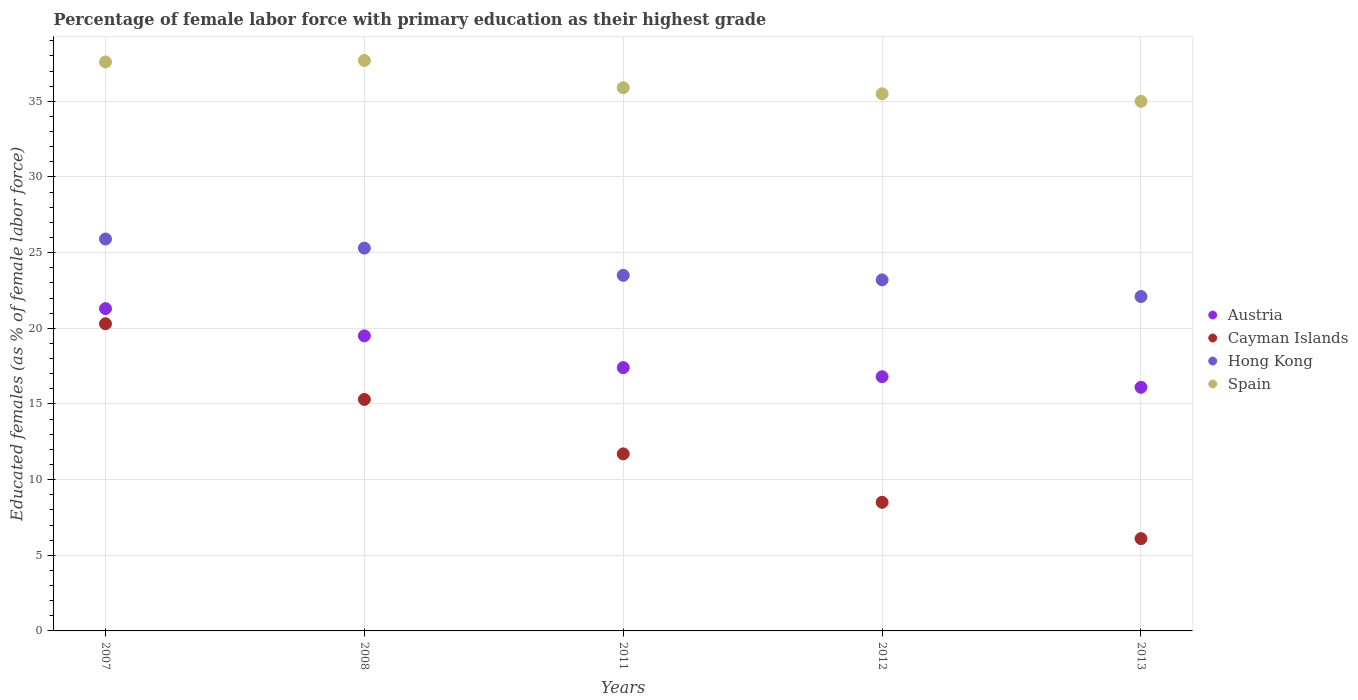Is the number of dotlines equal to the number of legend labels?
Your answer should be very brief. Yes. What is the percentage of female labor force with primary education in Hong Kong in 2012?
Give a very brief answer. 23.2. Across all years, what is the maximum percentage of female labor force with primary education in Cayman Islands?
Offer a very short reply. 20.3. Across all years, what is the minimum percentage of female labor force with primary education in Cayman Islands?
Give a very brief answer. 6.1. In which year was the percentage of female labor force with primary education in Cayman Islands maximum?
Ensure brevity in your answer.  2007. In which year was the percentage of female labor force with primary education in Hong Kong minimum?
Keep it short and to the point. 2013. What is the total percentage of female labor force with primary education in Cayman Islands in the graph?
Give a very brief answer. 61.9. What is the difference between the percentage of female labor force with primary education in Hong Kong in 2012 and that in 2013?
Your response must be concise. 1.1. What is the difference between the percentage of female labor force with primary education in Spain in 2011 and the percentage of female labor force with primary education in Hong Kong in 2007?
Keep it short and to the point. 10. What is the average percentage of female labor force with primary education in Hong Kong per year?
Provide a short and direct response. 24. What is the ratio of the percentage of female labor force with primary education in Cayman Islands in 2011 to that in 2012?
Make the answer very short. 1.38. What is the difference between the highest and the second highest percentage of female labor force with primary education in Hong Kong?
Ensure brevity in your answer.  0.6. What is the difference between the highest and the lowest percentage of female labor force with primary education in Hong Kong?
Offer a very short reply. 3.8. In how many years, is the percentage of female labor force with primary education in Hong Kong greater than the average percentage of female labor force with primary education in Hong Kong taken over all years?
Make the answer very short. 2. Is the sum of the percentage of female labor force with primary education in Hong Kong in 2007 and 2012 greater than the maximum percentage of female labor force with primary education in Cayman Islands across all years?
Ensure brevity in your answer.  Yes. Is it the case that in every year, the sum of the percentage of female labor force with primary education in Spain and percentage of female labor force with primary education in Austria  is greater than the sum of percentage of female labor force with primary education in Hong Kong and percentage of female labor force with primary education in Cayman Islands?
Give a very brief answer. No. Does the percentage of female labor force with primary education in Austria monotonically increase over the years?
Ensure brevity in your answer.  No. What is the difference between two consecutive major ticks on the Y-axis?
Ensure brevity in your answer.  5. Are the values on the major ticks of Y-axis written in scientific E-notation?
Your answer should be very brief. No. Where does the legend appear in the graph?
Provide a succinct answer. Center right. How many legend labels are there?
Ensure brevity in your answer.  4. How are the legend labels stacked?
Your response must be concise. Vertical. What is the title of the graph?
Your answer should be compact. Percentage of female labor force with primary education as their highest grade. What is the label or title of the Y-axis?
Offer a terse response. Educated females (as % of female labor force). What is the Educated females (as % of female labor force) of Austria in 2007?
Offer a very short reply. 21.3. What is the Educated females (as % of female labor force) of Cayman Islands in 2007?
Your response must be concise. 20.3. What is the Educated females (as % of female labor force) in Hong Kong in 2007?
Your response must be concise. 25.9. What is the Educated females (as % of female labor force) of Spain in 2007?
Provide a short and direct response. 37.6. What is the Educated females (as % of female labor force) of Austria in 2008?
Offer a terse response. 19.5. What is the Educated females (as % of female labor force) in Cayman Islands in 2008?
Offer a very short reply. 15.3. What is the Educated females (as % of female labor force) of Hong Kong in 2008?
Make the answer very short. 25.3. What is the Educated females (as % of female labor force) of Spain in 2008?
Offer a very short reply. 37.7. What is the Educated females (as % of female labor force) of Austria in 2011?
Your answer should be very brief. 17.4. What is the Educated females (as % of female labor force) of Cayman Islands in 2011?
Your answer should be very brief. 11.7. What is the Educated females (as % of female labor force) of Spain in 2011?
Ensure brevity in your answer.  35.9. What is the Educated females (as % of female labor force) of Austria in 2012?
Your response must be concise. 16.8. What is the Educated females (as % of female labor force) in Hong Kong in 2012?
Your answer should be very brief. 23.2. What is the Educated females (as % of female labor force) of Spain in 2012?
Keep it short and to the point. 35.5. What is the Educated females (as % of female labor force) in Austria in 2013?
Give a very brief answer. 16.1. What is the Educated females (as % of female labor force) in Cayman Islands in 2013?
Your response must be concise. 6.1. What is the Educated females (as % of female labor force) in Hong Kong in 2013?
Offer a very short reply. 22.1. Across all years, what is the maximum Educated females (as % of female labor force) in Austria?
Your answer should be very brief. 21.3. Across all years, what is the maximum Educated females (as % of female labor force) of Cayman Islands?
Your response must be concise. 20.3. Across all years, what is the maximum Educated females (as % of female labor force) of Hong Kong?
Offer a very short reply. 25.9. Across all years, what is the maximum Educated females (as % of female labor force) in Spain?
Provide a short and direct response. 37.7. Across all years, what is the minimum Educated females (as % of female labor force) in Austria?
Offer a terse response. 16.1. Across all years, what is the minimum Educated females (as % of female labor force) in Cayman Islands?
Keep it short and to the point. 6.1. Across all years, what is the minimum Educated females (as % of female labor force) of Hong Kong?
Offer a terse response. 22.1. Across all years, what is the minimum Educated females (as % of female labor force) of Spain?
Make the answer very short. 35. What is the total Educated females (as % of female labor force) in Austria in the graph?
Your answer should be compact. 91.1. What is the total Educated females (as % of female labor force) in Cayman Islands in the graph?
Your answer should be very brief. 61.9. What is the total Educated females (as % of female labor force) in Hong Kong in the graph?
Keep it short and to the point. 120. What is the total Educated females (as % of female labor force) in Spain in the graph?
Your answer should be very brief. 181.7. What is the difference between the Educated females (as % of female labor force) in Austria in 2007 and that in 2008?
Give a very brief answer. 1.8. What is the difference between the Educated females (as % of female labor force) in Austria in 2007 and that in 2011?
Offer a very short reply. 3.9. What is the difference between the Educated females (as % of female labor force) in Hong Kong in 2007 and that in 2011?
Your answer should be very brief. 2.4. What is the difference between the Educated females (as % of female labor force) of Spain in 2007 and that in 2011?
Provide a short and direct response. 1.7. What is the difference between the Educated females (as % of female labor force) of Austria in 2007 and that in 2012?
Provide a succinct answer. 4.5. What is the difference between the Educated females (as % of female labor force) of Hong Kong in 2007 and that in 2012?
Your answer should be very brief. 2.7. What is the difference between the Educated females (as % of female labor force) in Spain in 2007 and that in 2012?
Your response must be concise. 2.1. What is the difference between the Educated females (as % of female labor force) of Austria in 2007 and that in 2013?
Provide a succinct answer. 5.2. What is the difference between the Educated females (as % of female labor force) in Cayman Islands in 2007 and that in 2013?
Your answer should be compact. 14.2. What is the difference between the Educated females (as % of female labor force) in Austria in 2008 and that in 2011?
Ensure brevity in your answer.  2.1. What is the difference between the Educated females (as % of female labor force) of Cayman Islands in 2008 and that in 2011?
Your response must be concise. 3.6. What is the difference between the Educated females (as % of female labor force) in Hong Kong in 2008 and that in 2011?
Provide a succinct answer. 1.8. What is the difference between the Educated females (as % of female labor force) of Spain in 2008 and that in 2011?
Give a very brief answer. 1.8. What is the difference between the Educated females (as % of female labor force) in Austria in 2008 and that in 2012?
Your response must be concise. 2.7. What is the difference between the Educated females (as % of female labor force) of Cayman Islands in 2008 and that in 2012?
Offer a very short reply. 6.8. What is the difference between the Educated females (as % of female labor force) of Cayman Islands in 2008 and that in 2013?
Your answer should be compact. 9.2. What is the difference between the Educated females (as % of female labor force) in Spain in 2008 and that in 2013?
Offer a very short reply. 2.7. What is the difference between the Educated females (as % of female labor force) of Austria in 2011 and that in 2012?
Keep it short and to the point. 0.6. What is the difference between the Educated females (as % of female labor force) of Austria in 2011 and that in 2013?
Your answer should be compact. 1.3. What is the difference between the Educated females (as % of female labor force) in Cayman Islands in 2011 and that in 2013?
Give a very brief answer. 5.6. What is the difference between the Educated females (as % of female labor force) in Hong Kong in 2011 and that in 2013?
Offer a very short reply. 1.4. What is the difference between the Educated females (as % of female labor force) in Austria in 2012 and that in 2013?
Keep it short and to the point. 0.7. What is the difference between the Educated females (as % of female labor force) of Cayman Islands in 2012 and that in 2013?
Provide a succinct answer. 2.4. What is the difference between the Educated females (as % of female labor force) in Hong Kong in 2012 and that in 2013?
Give a very brief answer. 1.1. What is the difference between the Educated females (as % of female labor force) in Spain in 2012 and that in 2013?
Ensure brevity in your answer.  0.5. What is the difference between the Educated females (as % of female labor force) of Austria in 2007 and the Educated females (as % of female labor force) of Spain in 2008?
Ensure brevity in your answer.  -16.4. What is the difference between the Educated females (as % of female labor force) in Cayman Islands in 2007 and the Educated females (as % of female labor force) in Spain in 2008?
Provide a succinct answer. -17.4. What is the difference between the Educated females (as % of female labor force) of Austria in 2007 and the Educated females (as % of female labor force) of Hong Kong in 2011?
Offer a very short reply. -2.2. What is the difference between the Educated females (as % of female labor force) of Austria in 2007 and the Educated females (as % of female labor force) of Spain in 2011?
Provide a succinct answer. -14.6. What is the difference between the Educated females (as % of female labor force) in Cayman Islands in 2007 and the Educated females (as % of female labor force) in Spain in 2011?
Offer a very short reply. -15.6. What is the difference between the Educated females (as % of female labor force) in Hong Kong in 2007 and the Educated females (as % of female labor force) in Spain in 2011?
Your answer should be very brief. -10. What is the difference between the Educated females (as % of female labor force) of Austria in 2007 and the Educated females (as % of female labor force) of Cayman Islands in 2012?
Your answer should be compact. 12.8. What is the difference between the Educated females (as % of female labor force) of Cayman Islands in 2007 and the Educated females (as % of female labor force) of Hong Kong in 2012?
Offer a very short reply. -2.9. What is the difference between the Educated females (as % of female labor force) of Cayman Islands in 2007 and the Educated females (as % of female labor force) of Spain in 2012?
Ensure brevity in your answer.  -15.2. What is the difference between the Educated females (as % of female labor force) of Austria in 2007 and the Educated females (as % of female labor force) of Cayman Islands in 2013?
Provide a short and direct response. 15.2. What is the difference between the Educated females (as % of female labor force) in Austria in 2007 and the Educated females (as % of female labor force) in Spain in 2013?
Provide a short and direct response. -13.7. What is the difference between the Educated females (as % of female labor force) of Cayman Islands in 2007 and the Educated females (as % of female labor force) of Hong Kong in 2013?
Your answer should be compact. -1.8. What is the difference between the Educated females (as % of female labor force) of Cayman Islands in 2007 and the Educated females (as % of female labor force) of Spain in 2013?
Keep it short and to the point. -14.7. What is the difference between the Educated females (as % of female labor force) in Hong Kong in 2007 and the Educated females (as % of female labor force) in Spain in 2013?
Make the answer very short. -9.1. What is the difference between the Educated females (as % of female labor force) in Austria in 2008 and the Educated females (as % of female labor force) in Cayman Islands in 2011?
Give a very brief answer. 7.8. What is the difference between the Educated females (as % of female labor force) of Austria in 2008 and the Educated females (as % of female labor force) of Hong Kong in 2011?
Provide a short and direct response. -4. What is the difference between the Educated females (as % of female labor force) in Austria in 2008 and the Educated females (as % of female labor force) in Spain in 2011?
Your answer should be compact. -16.4. What is the difference between the Educated females (as % of female labor force) in Cayman Islands in 2008 and the Educated females (as % of female labor force) in Spain in 2011?
Your answer should be compact. -20.6. What is the difference between the Educated females (as % of female labor force) in Austria in 2008 and the Educated females (as % of female labor force) in Hong Kong in 2012?
Your response must be concise. -3.7. What is the difference between the Educated females (as % of female labor force) of Cayman Islands in 2008 and the Educated females (as % of female labor force) of Hong Kong in 2012?
Give a very brief answer. -7.9. What is the difference between the Educated females (as % of female labor force) in Cayman Islands in 2008 and the Educated females (as % of female labor force) in Spain in 2012?
Provide a succinct answer. -20.2. What is the difference between the Educated females (as % of female labor force) of Hong Kong in 2008 and the Educated females (as % of female labor force) of Spain in 2012?
Your answer should be very brief. -10.2. What is the difference between the Educated females (as % of female labor force) in Austria in 2008 and the Educated females (as % of female labor force) in Cayman Islands in 2013?
Your response must be concise. 13.4. What is the difference between the Educated females (as % of female labor force) of Austria in 2008 and the Educated females (as % of female labor force) of Spain in 2013?
Make the answer very short. -15.5. What is the difference between the Educated females (as % of female labor force) of Cayman Islands in 2008 and the Educated females (as % of female labor force) of Spain in 2013?
Your answer should be very brief. -19.7. What is the difference between the Educated females (as % of female labor force) in Hong Kong in 2008 and the Educated females (as % of female labor force) in Spain in 2013?
Your answer should be very brief. -9.7. What is the difference between the Educated females (as % of female labor force) in Austria in 2011 and the Educated females (as % of female labor force) in Hong Kong in 2012?
Offer a terse response. -5.8. What is the difference between the Educated females (as % of female labor force) in Austria in 2011 and the Educated females (as % of female labor force) in Spain in 2012?
Ensure brevity in your answer.  -18.1. What is the difference between the Educated females (as % of female labor force) in Cayman Islands in 2011 and the Educated females (as % of female labor force) in Spain in 2012?
Your response must be concise. -23.8. What is the difference between the Educated females (as % of female labor force) in Austria in 2011 and the Educated females (as % of female labor force) in Hong Kong in 2013?
Ensure brevity in your answer.  -4.7. What is the difference between the Educated females (as % of female labor force) in Austria in 2011 and the Educated females (as % of female labor force) in Spain in 2013?
Your answer should be very brief. -17.6. What is the difference between the Educated females (as % of female labor force) of Cayman Islands in 2011 and the Educated females (as % of female labor force) of Hong Kong in 2013?
Your response must be concise. -10.4. What is the difference between the Educated females (as % of female labor force) of Cayman Islands in 2011 and the Educated females (as % of female labor force) of Spain in 2013?
Give a very brief answer. -23.3. What is the difference between the Educated females (as % of female labor force) in Austria in 2012 and the Educated females (as % of female labor force) in Cayman Islands in 2013?
Make the answer very short. 10.7. What is the difference between the Educated females (as % of female labor force) of Austria in 2012 and the Educated females (as % of female labor force) of Hong Kong in 2013?
Provide a succinct answer. -5.3. What is the difference between the Educated females (as % of female labor force) of Austria in 2012 and the Educated females (as % of female labor force) of Spain in 2013?
Give a very brief answer. -18.2. What is the difference between the Educated females (as % of female labor force) of Cayman Islands in 2012 and the Educated females (as % of female labor force) of Hong Kong in 2013?
Ensure brevity in your answer.  -13.6. What is the difference between the Educated females (as % of female labor force) in Cayman Islands in 2012 and the Educated females (as % of female labor force) in Spain in 2013?
Your answer should be compact. -26.5. What is the difference between the Educated females (as % of female labor force) in Hong Kong in 2012 and the Educated females (as % of female labor force) in Spain in 2013?
Provide a short and direct response. -11.8. What is the average Educated females (as % of female labor force) in Austria per year?
Keep it short and to the point. 18.22. What is the average Educated females (as % of female labor force) of Cayman Islands per year?
Keep it short and to the point. 12.38. What is the average Educated females (as % of female labor force) in Hong Kong per year?
Offer a very short reply. 24. What is the average Educated females (as % of female labor force) in Spain per year?
Make the answer very short. 36.34. In the year 2007, what is the difference between the Educated females (as % of female labor force) in Austria and Educated females (as % of female labor force) in Spain?
Keep it short and to the point. -16.3. In the year 2007, what is the difference between the Educated females (as % of female labor force) of Cayman Islands and Educated females (as % of female labor force) of Spain?
Give a very brief answer. -17.3. In the year 2007, what is the difference between the Educated females (as % of female labor force) of Hong Kong and Educated females (as % of female labor force) of Spain?
Ensure brevity in your answer.  -11.7. In the year 2008, what is the difference between the Educated females (as % of female labor force) of Austria and Educated females (as % of female labor force) of Cayman Islands?
Give a very brief answer. 4.2. In the year 2008, what is the difference between the Educated females (as % of female labor force) in Austria and Educated females (as % of female labor force) in Spain?
Give a very brief answer. -18.2. In the year 2008, what is the difference between the Educated females (as % of female labor force) in Cayman Islands and Educated females (as % of female labor force) in Hong Kong?
Give a very brief answer. -10. In the year 2008, what is the difference between the Educated females (as % of female labor force) in Cayman Islands and Educated females (as % of female labor force) in Spain?
Keep it short and to the point. -22.4. In the year 2008, what is the difference between the Educated females (as % of female labor force) in Hong Kong and Educated females (as % of female labor force) in Spain?
Keep it short and to the point. -12.4. In the year 2011, what is the difference between the Educated females (as % of female labor force) in Austria and Educated females (as % of female labor force) in Cayman Islands?
Offer a very short reply. 5.7. In the year 2011, what is the difference between the Educated females (as % of female labor force) of Austria and Educated females (as % of female labor force) of Hong Kong?
Keep it short and to the point. -6.1. In the year 2011, what is the difference between the Educated females (as % of female labor force) of Austria and Educated females (as % of female labor force) of Spain?
Provide a short and direct response. -18.5. In the year 2011, what is the difference between the Educated females (as % of female labor force) in Cayman Islands and Educated females (as % of female labor force) in Hong Kong?
Your answer should be compact. -11.8. In the year 2011, what is the difference between the Educated females (as % of female labor force) in Cayman Islands and Educated females (as % of female labor force) in Spain?
Your answer should be compact. -24.2. In the year 2011, what is the difference between the Educated females (as % of female labor force) of Hong Kong and Educated females (as % of female labor force) of Spain?
Offer a terse response. -12.4. In the year 2012, what is the difference between the Educated females (as % of female labor force) of Austria and Educated females (as % of female labor force) of Cayman Islands?
Ensure brevity in your answer.  8.3. In the year 2012, what is the difference between the Educated females (as % of female labor force) in Austria and Educated females (as % of female labor force) in Hong Kong?
Your response must be concise. -6.4. In the year 2012, what is the difference between the Educated females (as % of female labor force) in Austria and Educated females (as % of female labor force) in Spain?
Give a very brief answer. -18.7. In the year 2012, what is the difference between the Educated females (as % of female labor force) of Cayman Islands and Educated females (as % of female labor force) of Hong Kong?
Provide a succinct answer. -14.7. In the year 2012, what is the difference between the Educated females (as % of female labor force) of Hong Kong and Educated females (as % of female labor force) of Spain?
Provide a succinct answer. -12.3. In the year 2013, what is the difference between the Educated females (as % of female labor force) in Austria and Educated females (as % of female labor force) in Hong Kong?
Provide a short and direct response. -6. In the year 2013, what is the difference between the Educated females (as % of female labor force) in Austria and Educated females (as % of female labor force) in Spain?
Offer a terse response. -18.9. In the year 2013, what is the difference between the Educated females (as % of female labor force) of Cayman Islands and Educated females (as % of female labor force) of Spain?
Provide a succinct answer. -28.9. What is the ratio of the Educated females (as % of female labor force) in Austria in 2007 to that in 2008?
Keep it short and to the point. 1.09. What is the ratio of the Educated females (as % of female labor force) in Cayman Islands in 2007 to that in 2008?
Provide a short and direct response. 1.33. What is the ratio of the Educated females (as % of female labor force) in Hong Kong in 2007 to that in 2008?
Your response must be concise. 1.02. What is the ratio of the Educated females (as % of female labor force) in Spain in 2007 to that in 2008?
Make the answer very short. 1. What is the ratio of the Educated females (as % of female labor force) in Austria in 2007 to that in 2011?
Offer a terse response. 1.22. What is the ratio of the Educated females (as % of female labor force) of Cayman Islands in 2007 to that in 2011?
Your answer should be very brief. 1.74. What is the ratio of the Educated females (as % of female labor force) in Hong Kong in 2007 to that in 2011?
Give a very brief answer. 1.1. What is the ratio of the Educated females (as % of female labor force) in Spain in 2007 to that in 2011?
Your response must be concise. 1.05. What is the ratio of the Educated females (as % of female labor force) in Austria in 2007 to that in 2012?
Give a very brief answer. 1.27. What is the ratio of the Educated females (as % of female labor force) in Cayman Islands in 2007 to that in 2012?
Offer a terse response. 2.39. What is the ratio of the Educated females (as % of female labor force) in Hong Kong in 2007 to that in 2012?
Provide a succinct answer. 1.12. What is the ratio of the Educated females (as % of female labor force) in Spain in 2007 to that in 2012?
Your answer should be very brief. 1.06. What is the ratio of the Educated females (as % of female labor force) in Austria in 2007 to that in 2013?
Keep it short and to the point. 1.32. What is the ratio of the Educated females (as % of female labor force) in Cayman Islands in 2007 to that in 2013?
Offer a terse response. 3.33. What is the ratio of the Educated females (as % of female labor force) in Hong Kong in 2007 to that in 2013?
Offer a very short reply. 1.17. What is the ratio of the Educated females (as % of female labor force) in Spain in 2007 to that in 2013?
Ensure brevity in your answer.  1.07. What is the ratio of the Educated females (as % of female labor force) in Austria in 2008 to that in 2011?
Your answer should be compact. 1.12. What is the ratio of the Educated females (as % of female labor force) of Cayman Islands in 2008 to that in 2011?
Your answer should be compact. 1.31. What is the ratio of the Educated females (as % of female labor force) of Hong Kong in 2008 to that in 2011?
Keep it short and to the point. 1.08. What is the ratio of the Educated females (as % of female labor force) in Spain in 2008 to that in 2011?
Provide a short and direct response. 1.05. What is the ratio of the Educated females (as % of female labor force) of Austria in 2008 to that in 2012?
Keep it short and to the point. 1.16. What is the ratio of the Educated females (as % of female labor force) in Hong Kong in 2008 to that in 2012?
Offer a very short reply. 1.09. What is the ratio of the Educated females (as % of female labor force) in Spain in 2008 to that in 2012?
Offer a very short reply. 1.06. What is the ratio of the Educated females (as % of female labor force) in Austria in 2008 to that in 2013?
Keep it short and to the point. 1.21. What is the ratio of the Educated females (as % of female labor force) in Cayman Islands in 2008 to that in 2013?
Give a very brief answer. 2.51. What is the ratio of the Educated females (as % of female labor force) of Hong Kong in 2008 to that in 2013?
Provide a short and direct response. 1.14. What is the ratio of the Educated females (as % of female labor force) in Spain in 2008 to that in 2013?
Keep it short and to the point. 1.08. What is the ratio of the Educated females (as % of female labor force) in Austria in 2011 to that in 2012?
Provide a succinct answer. 1.04. What is the ratio of the Educated females (as % of female labor force) of Cayman Islands in 2011 to that in 2012?
Keep it short and to the point. 1.38. What is the ratio of the Educated females (as % of female labor force) in Hong Kong in 2011 to that in 2012?
Offer a terse response. 1.01. What is the ratio of the Educated females (as % of female labor force) in Spain in 2011 to that in 2012?
Ensure brevity in your answer.  1.01. What is the ratio of the Educated females (as % of female labor force) in Austria in 2011 to that in 2013?
Your answer should be very brief. 1.08. What is the ratio of the Educated females (as % of female labor force) of Cayman Islands in 2011 to that in 2013?
Ensure brevity in your answer.  1.92. What is the ratio of the Educated females (as % of female labor force) of Hong Kong in 2011 to that in 2013?
Keep it short and to the point. 1.06. What is the ratio of the Educated females (as % of female labor force) in Spain in 2011 to that in 2013?
Your response must be concise. 1.03. What is the ratio of the Educated females (as % of female labor force) of Austria in 2012 to that in 2013?
Your answer should be compact. 1.04. What is the ratio of the Educated females (as % of female labor force) in Cayman Islands in 2012 to that in 2013?
Offer a terse response. 1.39. What is the ratio of the Educated females (as % of female labor force) of Hong Kong in 2012 to that in 2013?
Offer a very short reply. 1.05. What is the ratio of the Educated females (as % of female labor force) in Spain in 2012 to that in 2013?
Your answer should be compact. 1.01. What is the difference between the highest and the second highest Educated females (as % of female labor force) of Cayman Islands?
Offer a terse response. 5. What is the difference between the highest and the lowest Educated females (as % of female labor force) of Austria?
Provide a succinct answer. 5.2. What is the difference between the highest and the lowest Educated females (as % of female labor force) of Hong Kong?
Provide a short and direct response. 3.8. 